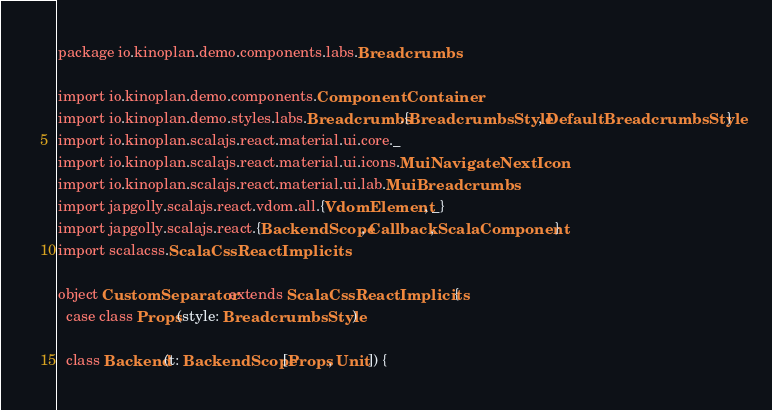<code> <loc_0><loc_0><loc_500><loc_500><_Scala_>package io.kinoplan.demo.components.labs.Breadcrumbs

import io.kinoplan.demo.components.ComponentContainer
import io.kinoplan.demo.styles.labs.Breadcrumbs.{BreadcrumbsStyle, DefaultBreadcrumbsStyle}
import io.kinoplan.scalajs.react.material.ui.core._
import io.kinoplan.scalajs.react.material.ui.icons.MuiNavigateNextIcon
import io.kinoplan.scalajs.react.material.ui.lab.MuiBreadcrumbs
import japgolly.scalajs.react.vdom.all.{VdomElement, _}
import japgolly.scalajs.react.{BackendScope, Callback, ScalaComponent}
import scalacss.ScalaCssReactImplicits

object CustomSeparator extends ScalaCssReactImplicits {
  case class Props(style: BreadcrumbsStyle)

  class Backend(t: BackendScope[Props, Unit]) {</code> 